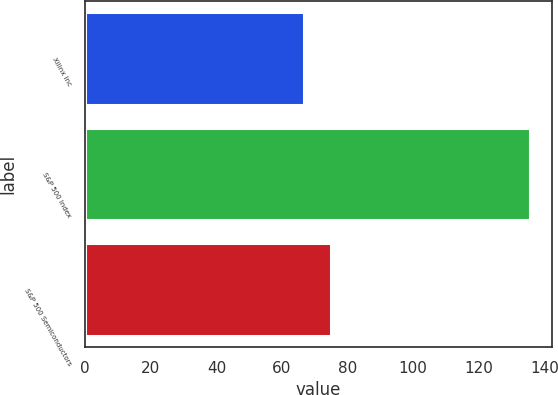<chart> <loc_0><loc_0><loc_500><loc_500><bar_chart><fcel>Xilinx Inc<fcel>S&P 500 Index<fcel>S&P 500 Semiconductors<nl><fcel>66.58<fcel>135.52<fcel>74.97<nl></chart> 